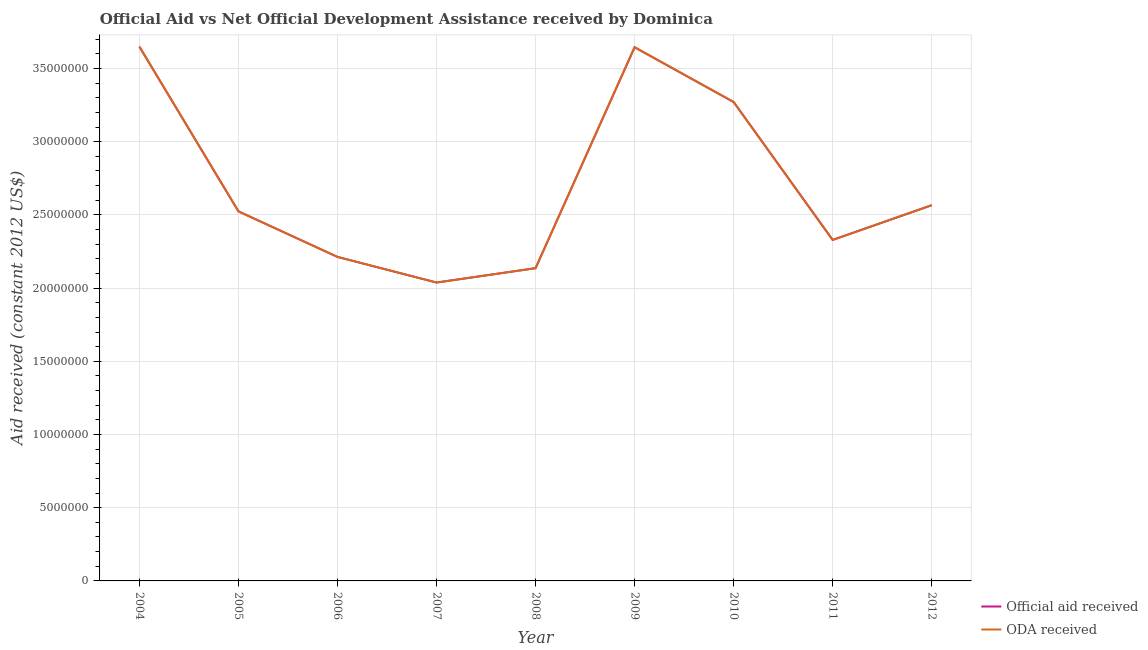How many different coloured lines are there?
Give a very brief answer. 2. What is the official aid received in 2006?
Make the answer very short. 2.21e+07. Across all years, what is the maximum official aid received?
Provide a succinct answer. 3.65e+07. Across all years, what is the minimum official aid received?
Keep it short and to the point. 2.04e+07. In which year was the oda received minimum?
Your answer should be compact. 2007. What is the total official aid received in the graph?
Make the answer very short. 2.44e+08. What is the difference between the oda received in 2008 and that in 2009?
Your answer should be compact. -1.51e+07. What is the difference between the oda received in 2004 and the official aid received in 2006?
Ensure brevity in your answer.  1.44e+07. What is the average oda received per year?
Your answer should be very brief. 2.71e+07. What is the ratio of the official aid received in 2007 to that in 2009?
Make the answer very short. 0.56. Is the oda received in 2009 less than that in 2010?
Ensure brevity in your answer.  No. Is the difference between the oda received in 2005 and 2007 greater than the difference between the official aid received in 2005 and 2007?
Offer a very short reply. No. What is the difference between the highest and the lowest official aid received?
Provide a short and direct response. 1.61e+07. Is the sum of the official aid received in 2010 and 2012 greater than the maximum oda received across all years?
Provide a short and direct response. Yes. Does the oda received monotonically increase over the years?
Your response must be concise. No. Is the oda received strictly greater than the official aid received over the years?
Provide a succinct answer. No. Is the oda received strictly less than the official aid received over the years?
Provide a short and direct response. No. Does the graph contain any zero values?
Offer a terse response. No. Does the graph contain grids?
Ensure brevity in your answer.  Yes. Where does the legend appear in the graph?
Ensure brevity in your answer.  Bottom right. How are the legend labels stacked?
Offer a very short reply. Vertical. What is the title of the graph?
Your answer should be very brief. Official Aid vs Net Official Development Assistance received by Dominica . What is the label or title of the X-axis?
Your response must be concise. Year. What is the label or title of the Y-axis?
Your response must be concise. Aid received (constant 2012 US$). What is the Aid received (constant 2012 US$) of Official aid received in 2004?
Offer a very short reply. 3.65e+07. What is the Aid received (constant 2012 US$) in ODA received in 2004?
Your response must be concise. 3.65e+07. What is the Aid received (constant 2012 US$) in Official aid received in 2005?
Your response must be concise. 2.52e+07. What is the Aid received (constant 2012 US$) in ODA received in 2005?
Ensure brevity in your answer.  2.52e+07. What is the Aid received (constant 2012 US$) in Official aid received in 2006?
Provide a succinct answer. 2.21e+07. What is the Aid received (constant 2012 US$) of ODA received in 2006?
Offer a very short reply. 2.21e+07. What is the Aid received (constant 2012 US$) of Official aid received in 2007?
Keep it short and to the point. 2.04e+07. What is the Aid received (constant 2012 US$) in ODA received in 2007?
Provide a succinct answer. 2.04e+07. What is the Aid received (constant 2012 US$) of Official aid received in 2008?
Ensure brevity in your answer.  2.14e+07. What is the Aid received (constant 2012 US$) in ODA received in 2008?
Offer a very short reply. 2.14e+07. What is the Aid received (constant 2012 US$) in Official aid received in 2009?
Your answer should be compact. 3.64e+07. What is the Aid received (constant 2012 US$) of ODA received in 2009?
Keep it short and to the point. 3.64e+07. What is the Aid received (constant 2012 US$) in Official aid received in 2010?
Offer a terse response. 3.27e+07. What is the Aid received (constant 2012 US$) of ODA received in 2010?
Provide a short and direct response. 3.27e+07. What is the Aid received (constant 2012 US$) of Official aid received in 2011?
Your answer should be compact. 2.33e+07. What is the Aid received (constant 2012 US$) of ODA received in 2011?
Keep it short and to the point. 2.33e+07. What is the Aid received (constant 2012 US$) in Official aid received in 2012?
Keep it short and to the point. 2.57e+07. What is the Aid received (constant 2012 US$) in ODA received in 2012?
Provide a short and direct response. 2.57e+07. Across all years, what is the maximum Aid received (constant 2012 US$) of Official aid received?
Provide a succinct answer. 3.65e+07. Across all years, what is the maximum Aid received (constant 2012 US$) in ODA received?
Your answer should be compact. 3.65e+07. Across all years, what is the minimum Aid received (constant 2012 US$) of Official aid received?
Offer a terse response. 2.04e+07. Across all years, what is the minimum Aid received (constant 2012 US$) of ODA received?
Ensure brevity in your answer.  2.04e+07. What is the total Aid received (constant 2012 US$) in Official aid received in the graph?
Make the answer very short. 2.44e+08. What is the total Aid received (constant 2012 US$) of ODA received in the graph?
Your answer should be very brief. 2.44e+08. What is the difference between the Aid received (constant 2012 US$) in Official aid received in 2004 and that in 2005?
Make the answer very short. 1.12e+07. What is the difference between the Aid received (constant 2012 US$) in ODA received in 2004 and that in 2005?
Offer a very short reply. 1.12e+07. What is the difference between the Aid received (constant 2012 US$) of Official aid received in 2004 and that in 2006?
Your response must be concise. 1.44e+07. What is the difference between the Aid received (constant 2012 US$) in ODA received in 2004 and that in 2006?
Provide a short and direct response. 1.44e+07. What is the difference between the Aid received (constant 2012 US$) of Official aid received in 2004 and that in 2007?
Make the answer very short. 1.61e+07. What is the difference between the Aid received (constant 2012 US$) in ODA received in 2004 and that in 2007?
Offer a terse response. 1.61e+07. What is the difference between the Aid received (constant 2012 US$) in Official aid received in 2004 and that in 2008?
Your answer should be compact. 1.51e+07. What is the difference between the Aid received (constant 2012 US$) of ODA received in 2004 and that in 2008?
Ensure brevity in your answer.  1.51e+07. What is the difference between the Aid received (constant 2012 US$) of Official aid received in 2004 and that in 2010?
Offer a very short reply. 3.78e+06. What is the difference between the Aid received (constant 2012 US$) of ODA received in 2004 and that in 2010?
Offer a very short reply. 3.78e+06. What is the difference between the Aid received (constant 2012 US$) in Official aid received in 2004 and that in 2011?
Give a very brief answer. 1.32e+07. What is the difference between the Aid received (constant 2012 US$) in ODA received in 2004 and that in 2011?
Your response must be concise. 1.32e+07. What is the difference between the Aid received (constant 2012 US$) in Official aid received in 2004 and that in 2012?
Make the answer very short. 1.08e+07. What is the difference between the Aid received (constant 2012 US$) of ODA received in 2004 and that in 2012?
Offer a very short reply. 1.08e+07. What is the difference between the Aid received (constant 2012 US$) of Official aid received in 2005 and that in 2006?
Provide a succinct answer. 3.11e+06. What is the difference between the Aid received (constant 2012 US$) in ODA received in 2005 and that in 2006?
Offer a terse response. 3.11e+06. What is the difference between the Aid received (constant 2012 US$) of Official aid received in 2005 and that in 2007?
Provide a succinct answer. 4.86e+06. What is the difference between the Aid received (constant 2012 US$) in ODA received in 2005 and that in 2007?
Your response must be concise. 4.86e+06. What is the difference between the Aid received (constant 2012 US$) of Official aid received in 2005 and that in 2008?
Provide a short and direct response. 3.88e+06. What is the difference between the Aid received (constant 2012 US$) in ODA received in 2005 and that in 2008?
Offer a terse response. 3.88e+06. What is the difference between the Aid received (constant 2012 US$) of Official aid received in 2005 and that in 2009?
Offer a very short reply. -1.12e+07. What is the difference between the Aid received (constant 2012 US$) in ODA received in 2005 and that in 2009?
Ensure brevity in your answer.  -1.12e+07. What is the difference between the Aid received (constant 2012 US$) of Official aid received in 2005 and that in 2010?
Offer a very short reply. -7.47e+06. What is the difference between the Aid received (constant 2012 US$) of ODA received in 2005 and that in 2010?
Your response must be concise. -7.47e+06. What is the difference between the Aid received (constant 2012 US$) in Official aid received in 2005 and that in 2011?
Make the answer very short. 1.95e+06. What is the difference between the Aid received (constant 2012 US$) in ODA received in 2005 and that in 2011?
Make the answer very short. 1.95e+06. What is the difference between the Aid received (constant 2012 US$) of Official aid received in 2005 and that in 2012?
Give a very brief answer. -4.20e+05. What is the difference between the Aid received (constant 2012 US$) in ODA received in 2005 and that in 2012?
Your answer should be compact. -4.20e+05. What is the difference between the Aid received (constant 2012 US$) in Official aid received in 2006 and that in 2007?
Keep it short and to the point. 1.75e+06. What is the difference between the Aid received (constant 2012 US$) in ODA received in 2006 and that in 2007?
Offer a terse response. 1.75e+06. What is the difference between the Aid received (constant 2012 US$) of Official aid received in 2006 and that in 2008?
Your answer should be very brief. 7.70e+05. What is the difference between the Aid received (constant 2012 US$) in ODA received in 2006 and that in 2008?
Keep it short and to the point. 7.70e+05. What is the difference between the Aid received (constant 2012 US$) in Official aid received in 2006 and that in 2009?
Ensure brevity in your answer.  -1.43e+07. What is the difference between the Aid received (constant 2012 US$) of ODA received in 2006 and that in 2009?
Ensure brevity in your answer.  -1.43e+07. What is the difference between the Aid received (constant 2012 US$) of Official aid received in 2006 and that in 2010?
Make the answer very short. -1.06e+07. What is the difference between the Aid received (constant 2012 US$) in ODA received in 2006 and that in 2010?
Provide a succinct answer. -1.06e+07. What is the difference between the Aid received (constant 2012 US$) of Official aid received in 2006 and that in 2011?
Give a very brief answer. -1.16e+06. What is the difference between the Aid received (constant 2012 US$) in ODA received in 2006 and that in 2011?
Keep it short and to the point. -1.16e+06. What is the difference between the Aid received (constant 2012 US$) in Official aid received in 2006 and that in 2012?
Keep it short and to the point. -3.53e+06. What is the difference between the Aid received (constant 2012 US$) of ODA received in 2006 and that in 2012?
Keep it short and to the point. -3.53e+06. What is the difference between the Aid received (constant 2012 US$) of Official aid received in 2007 and that in 2008?
Your answer should be very brief. -9.80e+05. What is the difference between the Aid received (constant 2012 US$) of ODA received in 2007 and that in 2008?
Offer a very short reply. -9.80e+05. What is the difference between the Aid received (constant 2012 US$) in Official aid received in 2007 and that in 2009?
Offer a terse response. -1.61e+07. What is the difference between the Aid received (constant 2012 US$) in ODA received in 2007 and that in 2009?
Offer a terse response. -1.61e+07. What is the difference between the Aid received (constant 2012 US$) in Official aid received in 2007 and that in 2010?
Your answer should be very brief. -1.23e+07. What is the difference between the Aid received (constant 2012 US$) of ODA received in 2007 and that in 2010?
Your response must be concise. -1.23e+07. What is the difference between the Aid received (constant 2012 US$) of Official aid received in 2007 and that in 2011?
Your response must be concise. -2.91e+06. What is the difference between the Aid received (constant 2012 US$) of ODA received in 2007 and that in 2011?
Offer a terse response. -2.91e+06. What is the difference between the Aid received (constant 2012 US$) of Official aid received in 2007 and that in 2012?
Ensure brevity in your answer.  -5.28e+06. What is the difference between the Aid received (constant 2012 US$) in ODA received in 2007 and that in 2012?
Offer a terse response. -5.28e+06. What is the difference between the Aid received (constant 2012 US$) in Official aid received in 2008 and that in 2009?
Give a very brief answer. -1.51e+07. What is the difference between the Aid received (constant 2012 US$) in ODA received in 2008 and that in 2009?
Give a very brief answer. -1.51e+07. What is the difference between the Aid received (constant 2012 US$) of Official aid received in 2008 and that in 2010?
Offer a terse response. -1.14e+07. What is the difference between the Aid received (constant 2012 US$) in ODA received in 2008 and that in 2010?
Give a very brief answer. -1.14e+07. What is the difference between the Aid received (constant 2012 US$) in Official aid received in 2008 and that in 2011?
Ensure brevity in your answer.  -1.93e+06. What is the difference between the Aid received (constant 2012 US$) of ODA received in 2008 and that in 2011?
Ensure brevity in your answer.  -1.93e+06. What is the difference between the Aid received (constant 2012 US$) of Official aid received in 2008 and that in 2012?
Your answer should be very brief. -4.30e+06. What is the difference between the Aid received (constant 2012 US$) of ODA received in 2008 and that in 2012?
Give a very brief answer. -4.30e+06. What is the difference between the Aid received (constant 2012 US$) of Official aid received in 2009 and that in 2010?
Provide a short and direct response. 3.74e+06. What is the difference between the Aid received (constant 2012 US$) of ODA received in 2009 and that in 2010?
Your answer should be very brief. 3.74e+06. What is the difference between the Aid received (constant 2012 US$) in Official aid received in 2009 and that in 2011?
Keep it short and to the point. 1.32e+07. What is the difference between the Aid received (constant 2012 US$) in ODA received in 2009 and that in 2011?
Keep it short and to the point. 1.32e+07. What is the difference between the Aid received (constant 2012 US$) of Official aid received in 2009 and that in 2012?
Your response must be concise. 1.08e+07. What is the difference between the Aid received (constant 2012 US$) in ODA received in 2009 and that in 2012?
Offer a very short reply. 1.08e+07. What is the difference between the Aid received (constant 2012 US$) of Official aid received in 2010 and that in 2011?
Give a very brief answer. 9.42e+06. What is the difference between the Aid received (constant 2012 US$) in ODA received in 2010 and that in 2011?
Offer a terse response. 9.42e+06. What is the difference between the Aid received (constant 2012 US$) of Official aid received in 2010 and that in 2012?
Provide a succinct answer. 7.05e+06. What is the difference between the Aid received (constant 2012 US$) of ODA received in 2010 and that in 2012?
Provide a short and direct response. 7.05e+06. What is the difference between the Aid received (constant 2012 US$) in Official aid received in 2011 and that in 2012?
Provide a short and direct response. -2.37e+06. What is the difference between the Aid received (constant 2012 US$) of ODA received in 2011 and that in 2012?
Make the answer very short. -2.37e+06. What is the difference between the Aid received (constant 2012 US$) in Official aid received in 2004 and the Aid received (constant 2012 US$) in ODA received in 2005?
Your answer should be compact. 1.12e+07. What is the difference between the Aid received (constant 2012 US$) in Official aid received in 2004 and the Aid received (constant 2012 US$) in ODA received in 2006?
Provide a short and direct response. 1.44e+07. What is the difference between the Aid received (constant 2012 US$) in Official aid received in 2004 and the Aid received (constant 2012 US$) in ODA received in 2007?
Provide a succinct answer. 1.61e+07. What is the difference between the Aid received (constant 2012 US$) of Official aid received in 2004 and the Aid received (constant 2012 US$) of ODA received in 2008?
Keep it short and to the point. 1.51e+07. What is the difference between the Aid received (constant 2012 US$) in Official aid received in 2004 and the Aid received (constant 2012 US$) in ODA received in 2009?
Keep it short and to the point. 4.00e+04. What is the difference between the Aid received (constant 2012 US$) of Official aid received in 2004 and the Aid received (constant 2012 US$) of ODA received in 2010?
Your response must be concise. 3.78e+06. What is the difference between the Aid received (constant 2012 US$) of Official aid received in 2004 and the Aid received (constant 2012 US$) of ODA received in 2011?
Provide a succinct answer. 1.32e+07. What is the difference between the Aid received (constant 2012 US$) of Official aid received in 2004 and the Aid received (constant 2012 US$) of ODA received in 2012?
Ensure brevity in your answer.  1.08e+07. What is the difference between the Aid received (constant 2012 US$) of Official aid received in 2005 and the Aid received (constant 2012 US$) of ODA received in 2006?
Offer a terse response. 3.11e+06. What is the difference between the Aid received (constant 2012 US$) in Official aid received in 2005 and the Aid received (constant 2012 US$) in ODA received in 2007?
Make the answer very short. 4.86e+06. What is the difference between the Aid received (constant 2012 US$) in Official aid received in 2005 and the Aid received (constant 2012 US$) in ODA received in 2008?
Make the answer very short. 3.88e+06. What is the difference between the Aid received (constant 2012 US$) in Official aid received in 2005 and the Aid received (constant 2012 US$) in ODA received in 2009?
Your response must be concise. -1.12e+07. What is the difference between the Aid received (constant 2012 US$) in Official aid received in 2005 and the Aid received (constant 2012 US$) in ODA received in 2010?
Provide a short and direct response. -7.47e+06. What is the difference between the Aid received (constant 2012 US$) in Official aid received in 2005 and the Aid received (constant 2012 US$) in ODA received in 2011?
Your answer should be compact. 1.95e+06. What is the difference between the Aid received (constant 2012 US$) in Official aid received in 2005 and the Aid received (constant 2012 US$) in ODA received in 2012?
Provide a short and direct response. -4.20e+05. What is the difference between the Aid received (constant 2012 US$) in Official aid received in 2006 and the Aid received (constant 2012 US$) in ODA received in 2007?
Your response must be concise. 1.75e+06. What is the difference between the Aid received (constant 2012 US$) of Official aid received in 2006 and the Aid received (constant 2012 US$) of ODA received in 2008?
Give a very brief answer. 7.70e+05. What is the difference between the Aid received (constant 2012 US$) in Official aid received in 2006 and the Aid received (constant 2012 US$) in ODA received in 2009?
Your response must be concise. -1.43e+07. What is the difference between the Aid received (constant 2012 US$) in Official aid received in 2006 and the Aid received (constant 2012 US$) in ODA received in 2010?
Provide a short and direct response. -1.06e+07. What is the difference between the Aid received (constant 2012 US$) in Official aid received in 2006 and the Aid received (constant 2012 US$) in ODA received in 2011?
Keep it short and to the point. -1.16e+06. What is the difference between the Aid received (constant 2012 US$) in Official aid received in 2006 and the Aid received (constant 2012 US$) in ODA received in 2012?
Provide a short and direct response. -3.53e+06. What is the difference between the Aid received (constant 2012 US$) of Official aid received in 2007 and the Aid received (constant 2012 US$) of ODA received in 2008?
Make the answer very short. -9.80e+05. What is the difference between the Aid received (constant 2012 US$) in Official aid received in 2007 and the Aid received (constant 2012 US$) in ODA received in 2009?
Ensure brevity in your answer.  -1.61e+07. What is the difference between the Aid received (constant 2012 US$) in Official aid received in 2007 and the Aid received (constant 2012 US$) in ODA received in 2010?
Provide a succinct answer. -1.23e+07. What is the difference between the Aid received (constant 2012 US$) in Official aid received in 2007 and the Aid received (constant 2012 US$) in ODA received in 2011?
Keep it short and to the point. -2.91e+06. What is the difference between the Aid received (constant 2012 US$) in Official aid received in 2007 and the Aid received (constant 2012 US$) in ODA received in 2012?
Ensure brevity in your answer.  -5.28e+06. What is the difference between the Aid received (constant 2012 US$) of Official aid received in 2008 and the Aid received (constant 2012 US$) of ODA received in 2009?
Your answer should be compact. -1.51e+07. What is the difference between the Aid received (constant 2012 US$) of Official aid received in 2008 and the Aid received (constant 2012 US$) of ODA received in 2010?
Keep it short and to the point. -1.14e+07. What is the difference between the Aid received (constant 2012 US$) of Official aid received in 2008 and the Aid received (constant 2012 US$) of ODA received in 2011?
Provide a short and direct response. -1.93e+06. What is the difference between the Aid received (constant 2012 US$) of Official aid received in 2008 and the Aid received (constant 2012 US$) of ODA received in 2012?
Make the answer very short. -4.30e+06. What is the difference between the Aid received (constant 2012 US$) in Official aid received in 2009 and the Aid received (constant 2012 US$) in ODA received in 2010?
Make the answer very short. 3.74e+06. What is the difference between the Aid received (constant 2012 US$) in Official aid received in 2009 and the Aid received (constant 2012 US$) in ODA received in 2011?
Ensure brevity in your answer.  1.32e+07. What is the difference between the Aid received (constant 2012 US$) in Official aid received in 2009 and the Aid received (constant 2012 US$) in ODA received in 2012?
Provide a short and direct response. 1.08e+07. What is the difference between the Aid received (constant 2012 US$) in Official aid received in 2010 and the Aid received (constant 2012 US$) in ODA received in 2011?
Keep it short and to the point. 9.42e+06. What is the difference between the Aid received (constant 2012 US$) in Official aid received in 2010 and the Aid received (constant 2012 US$) in ODA received in 2012?
Offer a very short reply. 7.05e+06. What is the difference between the Aid received (constant 2012 US$) in Official aid received in 2011 and the Aid received (constant 2012 US$) in ODA received in 2012?
Provide a short and direct response. -2.37e+06. What is the average Aid received (constant 2012 US$) of Official aid received per year?
Your answer should be very brief. 2.71e+07. What is the average Aid received (constant 2012 US$) of ODA received per year?
Offer a very short reply. 2.71e+07. In the year 2005, what is the difference between the Aid received (constant 2012 US$) of Official aid received and Aid received (constant 2012 US$) of ODA received?
Keep it short and to the point. 0. In the year 2006, what is the difference between the Aid received (constant 2012 US$) of Official aid received and Aid received (constant 2012 US$) of ODA received?
Your answer should be compact. 0. In the year 2009, what is the difference between the Aid received (constant 2012 US$) of Official aid received and Aid received (constant 2012 US$) of ODA received?
Offer a very short reply. 0. In the year 2010, what is the difference between the Aid received (constant 2012 US$) of Official aid received and Aid received (constant 2012 US$) of ODA received?
Your answer should be compact. 0. In the year 2012, what is the difference between the Aid received (constant 2012 US$) of Official aid received and Aid received (constant 2012 US$) of ODA received?
Offer a very short reply. 0. What is the ratio of the Aid received (constant 2012 US$) in Official aid received in 2004 to that in 2005?
Make the answer very short. 1.45. What is the ratio of the Aid received (constant 2012 US$) in ODA received in 2004 to that in 2005?
Offer a terse response. 1.45. What is the ratio of the Aid received (constant 2012 US$) of Official aid received in 2004 to that in 2006?
Your response must be concise. 1.65. What is the ratio of the Aid received (constant 2012 US$) in ODA received in 2004 to that in 2006?
Offer a terse response. 1.65. What is the ratio of the Aid received (constant 2012 US$) of Official aid received in 2004 to that in 2007?
Keep it short and to the point. 1.79. What is the ratio of the Aid received (constant 2012 US$) of ODA received in 2004 to that in 2007?
Offer a very short reply. 1.79. What is the ratio of the Aid received (constant 2012 US$) of Official aid received in 2004 to that in 2008?
Provide a short and direct response. 1.71. What is the ratio of the Aid received (constant 2012 US$) in ODA received in 2004 to that in 2008?
Keep it short and to the point. 1.71. What is the ratio of the Aid received (constant 2012 US$) in ODA received in 2004 to that in 2009?
Provide a short and direct response. 1. What is the ratio of the Aid received (constant 2012 US$) of Official aid received in 2004 to that in 2010?
Offer a terse response. 1.12. What is the ratio of the Aid received (constant 2012 US$) in ODA received in 2004 to that in 2010?
Provide a short and direct response. 1.12. What is the ratio of the Aid received (constant 2012 US$) in Official aid received in 2004 to that in 2011?
Your answer should be very brief. 1.57. What is the ratio of the Aid received (constant 2012 US$) in ODA received in 2004 to that in 2011?
Your answer should be very brief. 1.57. What is the ratio of the Aid received (constant 2012 US$) in Official aid received in 2004 to that in 2012?
Ensure brevity in your answer.  1.42. What is the ratio of the Aid received (constant 2012 US$) of ODA received in 2004 to that in 2012?
Your answer should be very brief. 1.42. What is the ratio of the Aid received (constant 2012 US$) of Official aid received in 2005 to that in 2006?
Provide a short and direct response. 1.14. What is the ratio of the Aid received (constant 2012 US$) of ODA received in 2005 to that in 2006?
Keep it short and to the point. 1.14. What is the ratio of the Aid received (constant 2012 US$) in Official aid received in 2005 to that in 2007?
Ensure brevity in your answer.  1.24. What is the ratio of the Aid received (constant 2012 US$) of ODA received in 2005 to that in 2007?
Offer a terse response. 1.24. What is the ratio of the Aid received (constant 2012 US$) of Official aid received in 2005 to that in 2008?
Keep it short and to the point. 1.18. What is the ratio of the Aid received (constant 2012 US$) in ODA received in 2005 to that in 2008?
Offer a terse response. 1.18. What is the ratio of the Aid received (constant 2012 US$) in Official aid received in 2005 to that in 2009?
Provide a short and direct response. 0.69. What is the ratio of the Aid received (constant 2012 US$) of ODA received in 2005 to that in 2009?
Keep it short and to the point. 0.69. What is the ratio of the Aid received (constant 2012 US$) in Official aid received in 2005 to that in 2010?
Ensure brevity in your answer.  0.77. What is the ratio of the Aid received (constant 2012 US$) in ODA received in 2005 to that in 2010?
Offer a very short reply. 0.77. What is the ratio of the Aid received (constant 2012 US$) in Official aid received in 2005 to that in 2011?
Provide a succinct answer. 1.08. What is the ratio of the Aid received (constant 2012 US$) of ODA received in 2005 to that in 2011?
Give a very brief answer. 1.08. What is the ratio of the Aid received (constant 2012 US$) of Official aid received in 2005 to that in 2012?
Offer a terse response. 0.98. What is the ratio of the Aid received (constant 2012 US$) of ODA received in 2005 to that in 2012?
Provide a succinct answer. 0.98. What is the ratio of the Aid received (constant 2012 US$) of Official aid received in 2006 to that in 2007?
Offer a terse response. 1.09. What is the ratio of the Aid received (constant 2012 US$) of ODA received in 2006 to that in 2007?
Your response must be concise. 1.09. What is the ratio of the Aid received (constant 2012 US$) in Official aid received in 2006 to that in 2008?
Provide a succinct answer. 1.04. What is the ratio of the Aid received (constant 2012 US$) of ODA received in 2006 to that in 2008?
Your answer should be compact. 1.04. What is the ratio of the Aid received (constant 2012 US$) in Official aid received in 2006 to that in 2009?
Ensure brevity in your answer.  0.61. What is the ratio of the Aid received (constant 2012 US$) in ODA received in 2006 to that in 2009?
Provide a short and direct response. 0.61. What is the ratio of the Aid received (constant 2012 US$) of Official aid received in 2006 to that in 2010?
Make the answer very short. 0.68. What is the ratio of the Aid received (constant 2012 US$) in ODA received in 2006 to that in 2010?
Your response must be concise. 0.68. What is the ratio of the Aid received (constant 2012 US$) of Official aid received in 2006 to that in 2011?
Ensure brevity in your answer.  0.95. What is the ratio of the Aid received (constant 2012 US$) in ODA received in 2006 to that in 2011?
Offer a very short reply. 0.95. What is the ratio of the Aid received (constant 2012 US$) of Official aid received in 2006 to that in 2012?
Keep it short and to the point. 0.86. What is the ratio of the Aid received (constant 2012 US$) in ODA received in 2006 to that in 2012?
Provide a short and direct response. 0.86. What is the ratio of the Aid received (constant 2012 US$) of Official aid received in 2007 to that in 2008?
Make the answer very short. 0.95. What is the ratio of the Aid received (constant 2012 US$) in ODA received in 2007 to that in 2008?
Make the answer very short. 0.95. What is the ratio of the Aid received (constant 2012 US$) of Official aid received in 2007 to that in 2009?
Offer a terse response. 0.56. What is the ratio of the Aid received (constant 2012 US$) of ODA received in 2007 to that in 2009?
Offer a terse response. 0.56. What is the ratio of the Aid received (constant 2012 US$) of Official aid received in 2007 to that in 2010?
Offer a very short reply. 0.62. What is the ratio of the Aid received (constant 2012 US$) in ODA received in 2007 to that in 2010?
Offer a very short reply. 0.62. What is the ratio of the Aid received (constant 2012 US$) of Official aid received in 2007 to that in 2011?
Give a very brief answer. 0.88. What is the ratio of the Aid received (constant 2012 US$) of ODA received in 2007 to that in 2011?
Make the answer very short. 0.88. What is the ratio of the Aid received (constant 2012 US$) in Official aid received in 2007 to that in 2012?
Keep it short and to the point. 0.79. What is the ratio of the Aid received (constant 2012 US$) in ODA received in 2007 to that in 2012?
Your answer should be very brief. 0.79. What is the ratio of the Aid received (constant 2012 US$) of Official aid received in 2008 to that in 2009?
Your answer should be compact. 0.59. What is the ratio of the Aid received (constant 2012 US$) of ODA received in 2008 to that in 2009?
Offer a very short reply. 0.59. What is the ratio of the Aid received (constant 2012 US$) of Official aid received in 2008 to that in 2010?
Your response must be concise. 0.65. What is the ratio of the Aid received (constant 2012 US$) of ODA received in 2008 to that in 2010?
Make the answer very short. 0.65. What is the ratio of the Aid received (constant 2012 US$) of Official aid received in 2008 to that in 2011?
Provide a short and direct response. 0.92. What is the ratio of the Aid received (constant 2012 US$) in ODA received in 2008 to that in 2011?
Your answer should be compact. 0.92. What is the ratio of the Aid received (constant 2012 US$) of Official aid received in 2008 to that in 2012?
Offer a terse response. 0.83. What is the ratio of the Aid received (constant 2012 US$) of ODA received in 2008 to that in 2012?
Provide a short and direct response. 0.83. What is the ratio of the Aid received (constant 2012 US$) in Official aid received in 2009 to that in 2010?
Offer a very short reply. 1.11. What is the ratio of the Aid received (constant 2012 US$) of ODA received in 2009 to that in 2010?
Your answer should be compact. 1.11. What is the ratio of the Aid received (constant 2012 US$) in Official aid received in 2009 to that in 2011?
Your answer should be compact. 1.56. What is the ratio of the Aid received (constant 2012 US$) of ODA received in 2009 to that in 2011?
Give a very brief answer. 1.56. What is the ratio of the Aid received (constant 2012 US$) in Official aid received in 2009 to that in 2012?
Make the answer very short. 1.42. What is the ratio of the Aid received (constant 2012 US$) in ODA received in 2009 to that in 2012?
Ensure brevity in your answer.  1.42. What is the ratio of the Aid received (constant 2012 US$) of Official aid received in 2010 to that in 2011?
Keep it short and to the point. 1.4. What is the ratio of the Aid received (constant 2012 US$) in ODA received in 2010 to that in 2011?
Provide a succinct answer. 1.4. What is the ratio of the Aid received (constant 2012 US$) of Official aid received in 2010 to that in 2012?
Keep it short and to the point. 1.27. What is the ratio of the Aid received (constant 2012 US$) in ODA received in 2010 to that in 2012?
Your response must be concise. 1.27. What is the ratio of the Aid received (constant 2012 US$) of Official aid received in 2011 to that in 2012?
Your answer should be very brief. 0.91. What is the ratio of the Aid received (constant 2012 US$) of ODA received in 2011 to that in 2012?
Your answer should be compact. 0.91. What is the difference between the highest and the second highest Aid received (constant 2012 US$) in Official aid received?
Provide a short and direct response. 4.00e+04. What is the difference between the highest and the lowest Aid received (constant 2012 US$) in Official aid received?
Offer a very short reply. 1.61e+07. What is the difference between the highest and the lowest Aid received (constant 2012 US$) of ODA received?
Offer a terse response. 1.61e+07. 